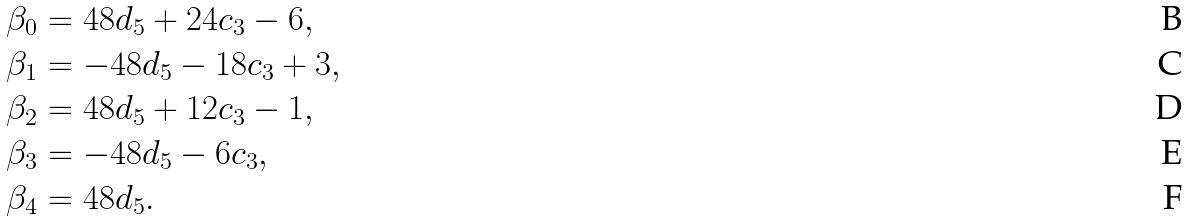Convert formula to latex. <formula><loc_0><loc_0><loc_500><loc_500>\beta _ { 0 } & = 4 8 d _ { 5 } + 2 4 c _ { 3 } - 6 , \\ \beta _ { 1 } & = - 4 8 d _ { 5 } - 1 8 c _ { 3 } + 3 , \\ \beta _ { 2 } & = 4 8 d _ { 5 } + 1 2 c _ { 3 } - 1 , \\ \beta _ { 3 } & = - 4 8 d _ { 5 } - 6 c _ { 3 } , \\ \beta _ { 4 } & = 4 8 d _ { 5 } .</formula> 